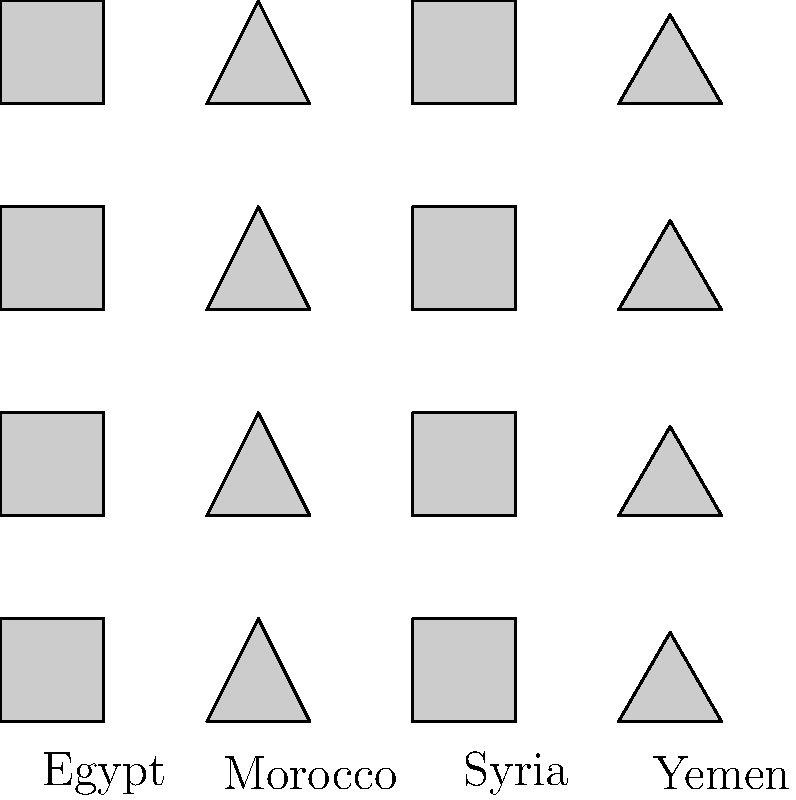Based on the geometric patterns shown in the image, which represents traditional textile designs from different Arab countries, calculate the ratio of the perimeter to the area for the basic unit of the Moroccan pattern. Assume the side length of the square grid is 1 unit. To solve this problem, let's follow these steps:

1. Identify the Moroccan pattern: It's the second from the left, a triangular shape.

2. Calculate the perimeter of the triangle:
   - Base = 1 unit
   - Height = 1 unit
   - Hypotenuse = $\sqrt{1^2 + 1^2} = \sqrt{2}$ units
   - Perimeter = $1 + 1 + \sqrt{2}$ units

3. Calculate the area of the triangle:
   - Area = $\frac{1}{2} \times base \times height = \frac{1}{2} \times 1 \times 1 = 0.5$ square units

4. Calculate the ratio of perimeter to area:
   Ratio = $\frac{Perimeter}{Area} = \frac{1 + 1 + \sqrt{2}}{0.5} = 2 + 2 + 2\sqrt{2}$

5. Simplify the ratio:
   $2 + 2 + 2\sqrt{2} = 4 + 2\sqrt{2}$

Therefore, the ratio of the perimeter to the area for the basic unit of the Moroccan pattern is $4 + 2\sqrt{2}$.
Answer: $4 + 2\sqrt{2}$ 